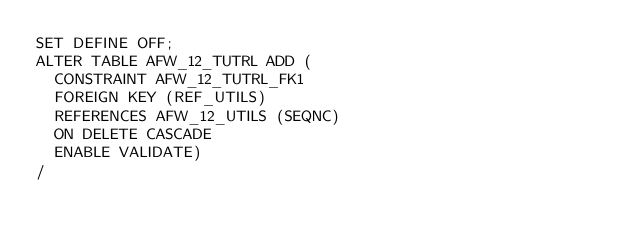Convert code to text. <code><loc_0><loc_0><loc_500><loc_500><_SQL_>SET DEFINE OFF;
ALTER TABLE AFW_12_TUTRL ADD (
  CONSTRAINT AFW_12_TUTRL_FK1 
  FOREIGN KEY (REF_UTILS) 
  REFERENCES AFW_12_UTILS (SEQNC)
  ON DELETE CASCADE
  ENABLE VALIDATE)
/
</code> 